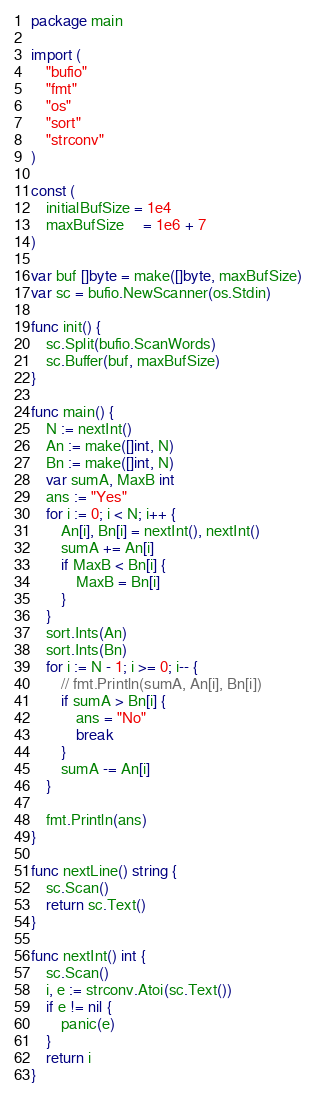<code> <loc_0><loc_0><loc_500><loc_500><_Go_>package main

import (
	"bufio"
	"fmt"
	"os"
	"sort"
	"strconv"
)

const (
	initialBufSize = 1e4
	maxBufSize     = 1e6 + 7
)

var buf []byte = make([]byte, maxBufSize)
var sc = bufio.NewScanner(os.Stdin)

func init() {
	sc.Split(bufio.ScanWords)
	sc.Buffer(buf, maxBufSize)
}

func main() {
	N := nextInt()
	An := make([]int, N)
	Bn := make([]int, N)
	var sumA, MaxB int
	ans := "Yes"
	for i := 0; i < N; i++ {
		An[i], Bn[i] = nextInt(), nextInt()
		sumA += An[i]
		if MaxB < Bn[i] {
			MaxB = Bn[i]
		}
	}
	sort.Ints(An)
	sort.Ints(Bn)
	for i := N - 1; i >= 0; i-- {
		// fmt.Println(sumA, An[i], Bn[i])
		if sumA > Bn[i] {
			ans = "No"
			break
		}
		sumA -= An[i]
	}

	fmt.Println(ans)
}

func nextLine() string {
	sc.Scan()
	return sc.Text()
}

func nextInt() int {
	sc.Scan()
	i, e := strconv.Atoi(sc.Text())
	if e != nil {
		panic(e)
	}
	return i
}
</code> 